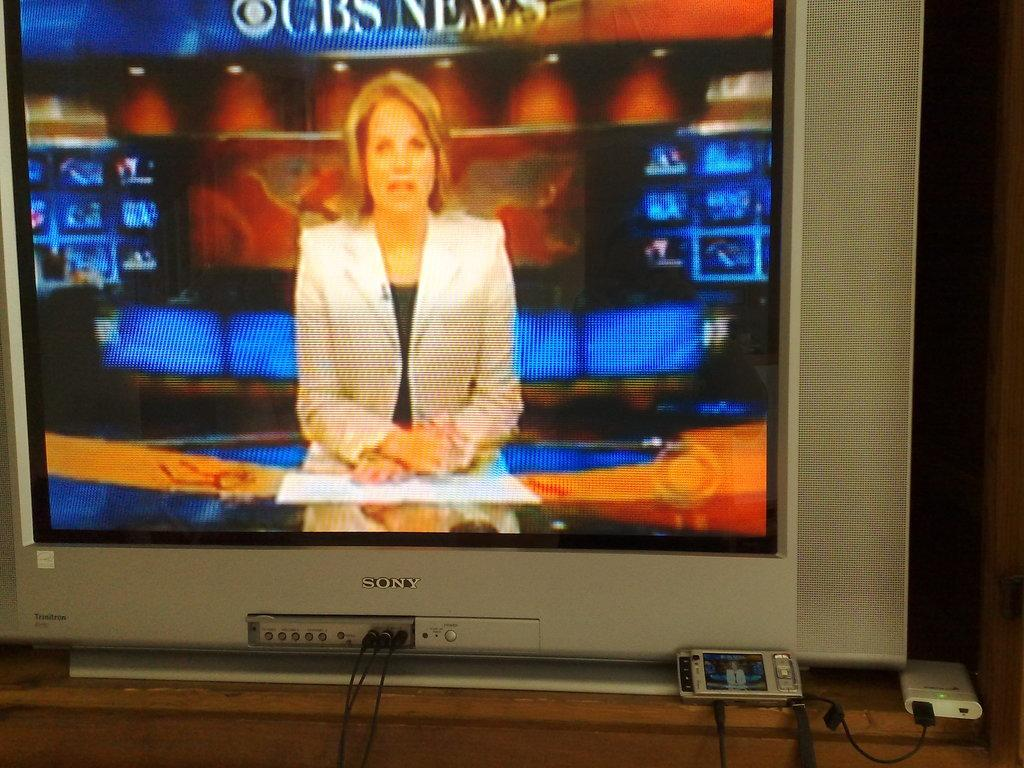<image>
Offer a succinct explanation of the picture presented. The CBS News is shown on a old Sony TV. 